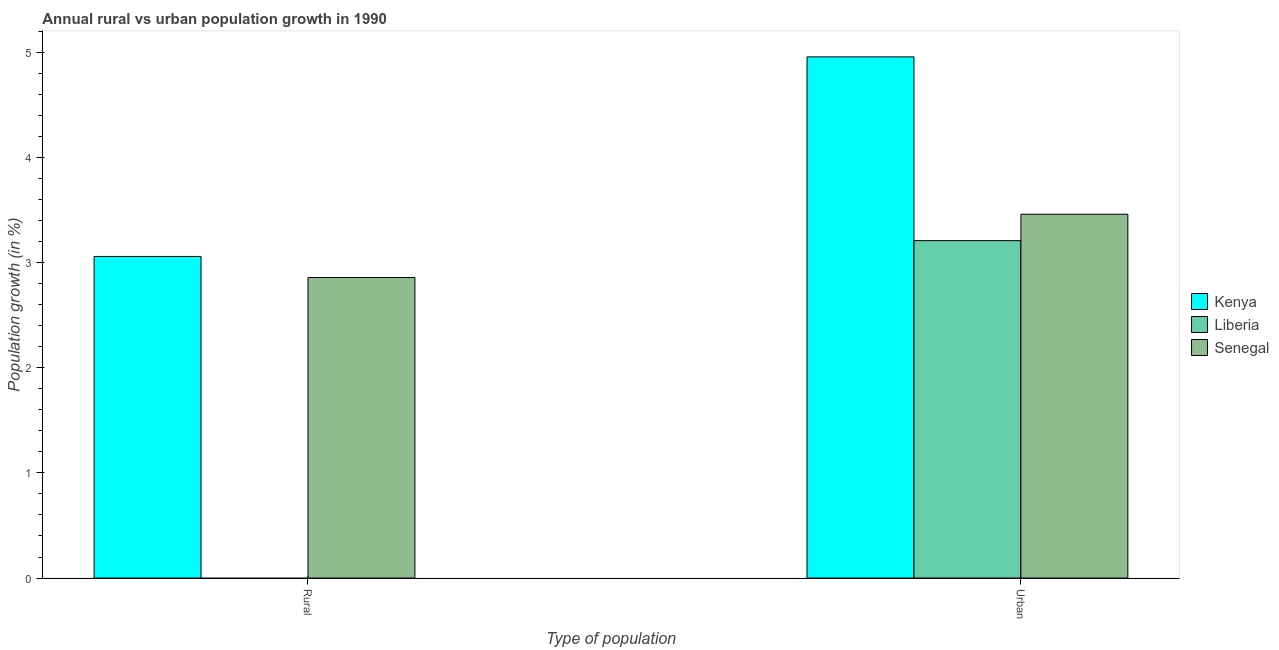How many different coloured bars are there?
Give a very brief answer. 3. Are the number of bars per tick equal to the number of legend labels?
Make the answer very short. No. Are the number of bars on each tick of the X-axis equal?
Ensure brevity in your answer.  No. How many bars are there on the 2nd tick from the left?
Offer a very short reply. 3. How many bars are there on the 2nd tick from the right?
Provide a succinct answer. 2. What is the label of the 1st group of bars from the left?
Provide a short and direct response. Rural. What is the urban population growth in Kenya?
Offer a terse response. 4.96. Across all countries, what is the maximum rural population growth?
Offer a terse response. 3.06. Across all countries, what is the minimum rural population growth?
Make the answer very short. 0. In which country was the urban population growth maximum?
Provide a short and direct response. Kenya. What is the total rural population growth in the graph?
Your answer should be compact. 5.92. What is the difference between the urban population growth in Senegal and that in Kenya?
Your answer should be very brief. -1.5. What is the difference between the urban population growth in Senegal and the rural population growth in Liberia?
Offer a very short reply. 3.46. What is the average rural population growth per country?
Ensure brevity in your answer.  1.97. What is the difference between the urban population growth and rural population growth in Kenya?
Keep it short and to the point. 1.9. In how many countries, is the urban population growth greater than 3.2 %?
Make the answer very short. 3. What is the ratio of the urban population growth in Liberia to that in Senegal?
Offer a very short reply. 0.93. Is the urban population growth in Liberia less than that in Kenya?
Offer a very short reply. Yes. Are all the bars in the graph horizontal?
Provide a succinct answer. No. What is the difference between two consecutive major ticks on the Y-axis?
Provide a succinct answer. 1. How many legend labels are there?
Your response must be concise. 3. How are the legend labels stacked?
Provide a succinct answer. Vertical. What is the title of the graph?
Your answer should be very brief. Annual rural vs urban population growth in 1990. What is the label or title of the X-axis?
Offer a very short reply. Type of population. What is the label or title of the Y-axis?
Offer a very short reply. Population growth (in %). What is the Population growth (in %) in Kenya in Rural?
Provide a short and direct response. 3.06. What is the Population growth (in %) in Liberia in Rural?
Offer a very short reply. 0. What is the Population growth (in %) in Senegal in Rural?
Your answer should be compact. 2.86. What is the Population growth (in %) of Kenya in Urban ?
Give a very brief answer. 4.96. What is the Population growth (in %) of Liberia in Urban ?
Provide a short and direct response. 3.21. What is the Population growth (in %) of Senegal in Urban ?
Your response must be concise. 3.46. Across all Type of population, what is the maximum Population growth (in %) in Kenya?
Ensure brevity in your answer.  4.96. Across all Type of population, what is the maximum Population growth (in %) of Liberia?
Give a very brief answer. 3.21. Across all Type of population, what is the maximum Population growth (in %) of Senegal?
Provide a short and direct response. 3.46. Across all Type of population, what is the minimum Population growth (in %) in Kenya?
Offer a very short reply. 3.06. Across all Type of population, what is the minimum Population growth (in %) in Senegal?
Keep it short and to the point. 2.86. What is the total Population growth (in %) in Kenya in the graph?
Give a very brief answer. 8.02. What is the total Population growth (in %) in Liberia in the graph?
Keep it short and to the point. 3.21. What is the total Population growth (in %) of Senegal in the graph?
Provide a short and direct response. 6.32. What is the difference between the Population growth (in %) of Kenya in Rural and that in Urban ?
Provide a succinct answer. -1.9. What is the difference between the Population growth (in %) in Senegal in Rural and that in Urban ?
Keep it short and to the point. -0.6. What is the difference between the Population growth (in %) of Kenya in Rural and the Population growth (in %) of Liberia in Urban?
Your answer should be very brief. -0.15. What is the difference between the Population growth (in %) in Kenya in Rural and the Population growth (in %) in Senegal in Urban?
Provide a succinct answer. -0.4. What is the average Population growth (in %) in Kenya per Type of population?
Your response must be concise. 4.01. What is the average Population growth (in %) in Liberia per Type of population?
Ensure brevity in your answer.  1.6. What is the average Population growth (in %) in Senegal per Type of population?
Provide a short and direct response. 3.16. What is the difference between the Population growth (in %) of Kenya and Population growth (in %) of Senegal in Rural?
Your answer should be compact. 0.2. What is the difference between the Population growth (in %) in Kenya and Population growth (in %) in Liberia in Urban ?
Make the answer very short. 1.75. What is the difference between the Population growth (in %) of Kenya and Population growth (in %) of Senegal in Urban ?
Your answer should be compact. 1.5. What is the difference between the Population growth (in %) of Liberia and Population growth (in %) of Senegal in Urban ?
Give a very brief answer. -0.25. What is the ratio of the Population growth (in %) in Kenya in Rural to that in Urban ?
Provide a succinct answer. 0.62. What is the ratio of the Population growth (in %) of Senegal in Rural to that in Urban ?
Keep it short and to the point. 0.83. What is the difference between the highest and the second highest Population growth (in %) in Kenya?
Provide a short and direct response. 1.9. What is the difference between the highest and the second highest Population growth (in %) of Senegal?
Offer a very short reply. 0.6. What is the difference between the highest and the lowest Population growth (in %) in Kenya?
Provide a succinct answer. 1.9. What is the difference between the highest and the lowest Population growth (in %) of Liberia?
Offer a terse response. 3.21. What is the difference between the highest and the lowest Population growth (in %) of Senegal?
Provide a short and direct response. 0.6. 